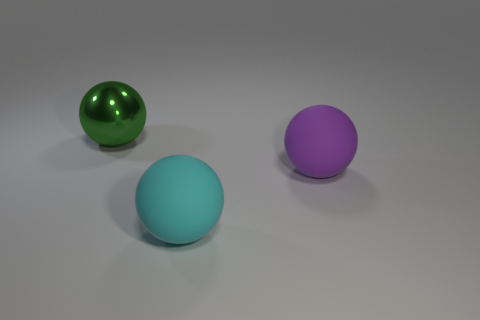Are there any other things that are the same material as the big green ball?
Ensure brevity in your answer.  No. How many cyan balls are in front of the green ball?
Provide a succinct answer. 1. There is another sphere that is made of the same material as the purple ball; what color is it?
Your answer should be very brief. Cyan. How many matte objects are either small purple blocks or cyan balls?
Offer a terse response. 1. Are the green object and the cyan thing made of the same material?
Make the answer very short. No. What shape is the large object behind the large purple ball?
Make the answer very short. Sphere. There is a large rubber sphere that is behind the large cyan object; are there any large cyan rubber balls that are in front of it?
Make the answer very short. Yes. Are there any cyan metallic blocks that have the same size as the purple ball?
Your answer should be very brief. No. What number of large objects have the same color as the large metal ball?
Make the answer very short. 0. How many purple matte spheres are there?
Make the answer very short. 1. 